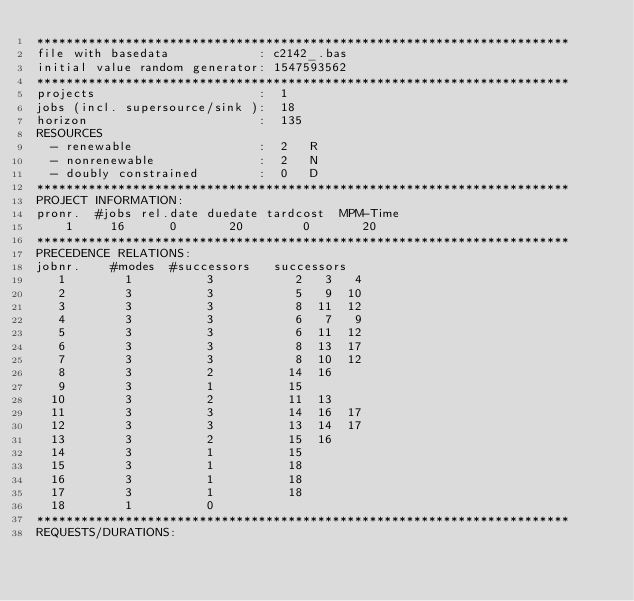<code> <loc_0><loc_0><loc_500><loc_500><_ObjectiveC_>************************************************************************
file with basedata            : c2142_.bas
initial value random generator: 1547593562
************************************************************************
projects                      :  1
jobs (incl. supersource/sink ):  18
horizon                       :  135
RESOURCES
  - renewable                 :  2   R
  - nonrenewable              :  2   N
  - doubly constrained        :  0   D
************************************************************************
PROJECT INFORMATION:
pronr.  #jobs rel.date duedate tardcost  MPM-Time
    1     16      0       20        0       20
************************************************************************
PRECEDENCE RELATIONS:
jobnr.    #modes  #successors   successors
   1        1          3           2   3   4
   2        3          3           5   9  10
   3        3          3           8  11  12
   4        3          3           6   7   9
   5        3          3           6  11  12
   6        3          3           8  13  17
   7        3          3           8  10  12
   8        3          2          14  16
   9        3          1          15
  10        3          2          11  13
  11        3          3          14  16  17
  12        3          3          13  14  17
  13        3          2          15  16
  14        3          1          15
  15        3          1          18
  16        3          1          18
  17        3          1          18
  18        1          0        
************************************************************************
REQUESTS/DURATIONS:</code> 